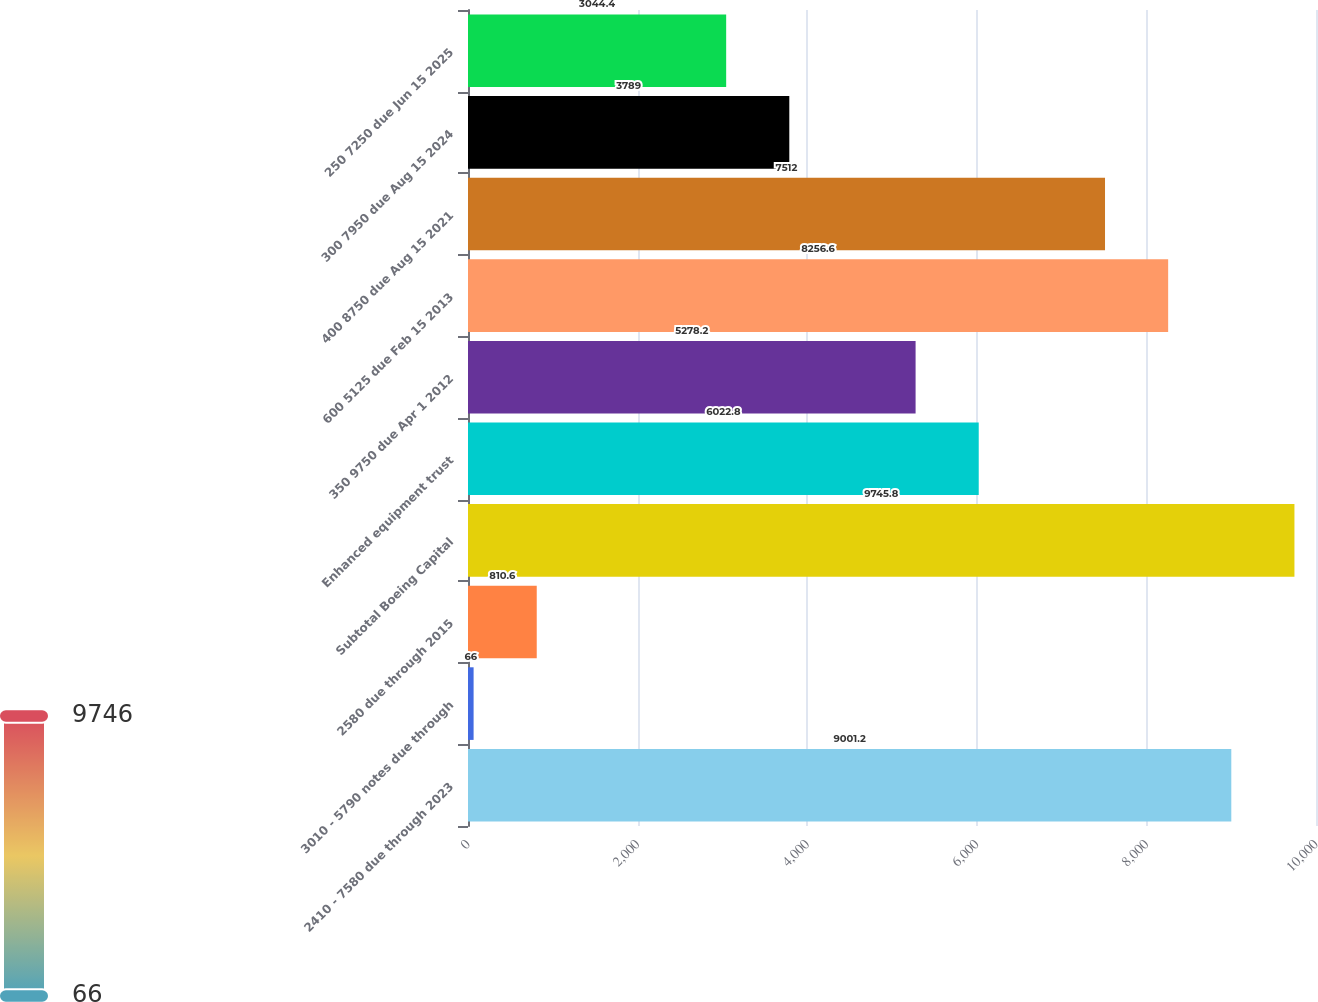<chart> <loc_0><loc_0><loc_500><loc_500><bar_chart><fcel>2410 - 7580 due through 2023<fcel>3010 - 5790 notes due through<fcel>2580 due through 2015<fcel>Subtotal Boeing Capital<fcel>Enhanced equipment trust<fcel>350 9750 due Apr 1 2012<fcel>600 5125 due Feb 15 2013<fcel>400 8750 due Aug 15 2021<fcel>300 7950 due Aug 15 2024<fcel>250 7250 due Jun 15 2025<nl><fcel>9001.2<fcel>66<fcel>810.6<fcel>9745.8<fcel>6022.8<fcel>5278.2<fcel>8256.6<fcel>7512<fcel>3789<fcel>3044.4<nl></chart> 